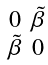Convert formula to latex. <formula><loc_0><loc_0><loc_500><loc_500>\begin{smallmatrix} 0 & \tilde { \beta } \\ \tilde { \beta } & 0 \end{smallmatrix}</formula> 